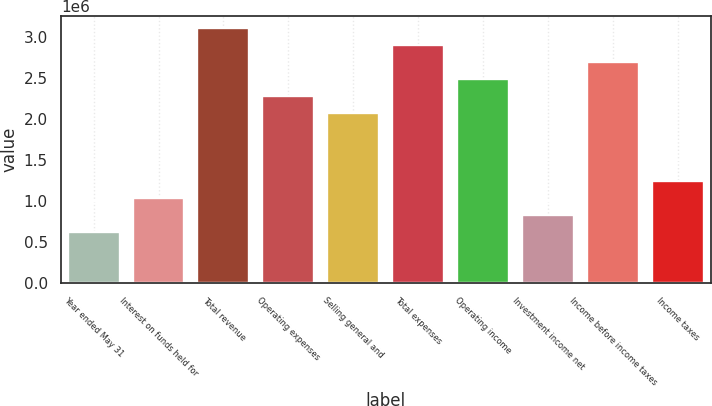Convert chart to OTSL. <chart><loc_0><loc_0><loc_500><loc_500><bar_chart><fcel>Year ended May 31<fcel>Interest on funds held for<fcel>Total revenue<fcel>Operating expenses<fcel>Selling general and<fcel>Total expenses<fcel>Operating income<fcel>Investment income net<fcel>Income before income taxes<fcel>Income taxes<nl><fcel>619898<fcel>1.03316e+06<fcel>3.09948e+06<fcel>2.27296e+06<fcel>2.06632e+06<fcel>2.89285e+06<fcel>2.47959e+06<fcel>826530<fcel>2.68622e+06<fcel>1.23979e+06<nl></chart> 